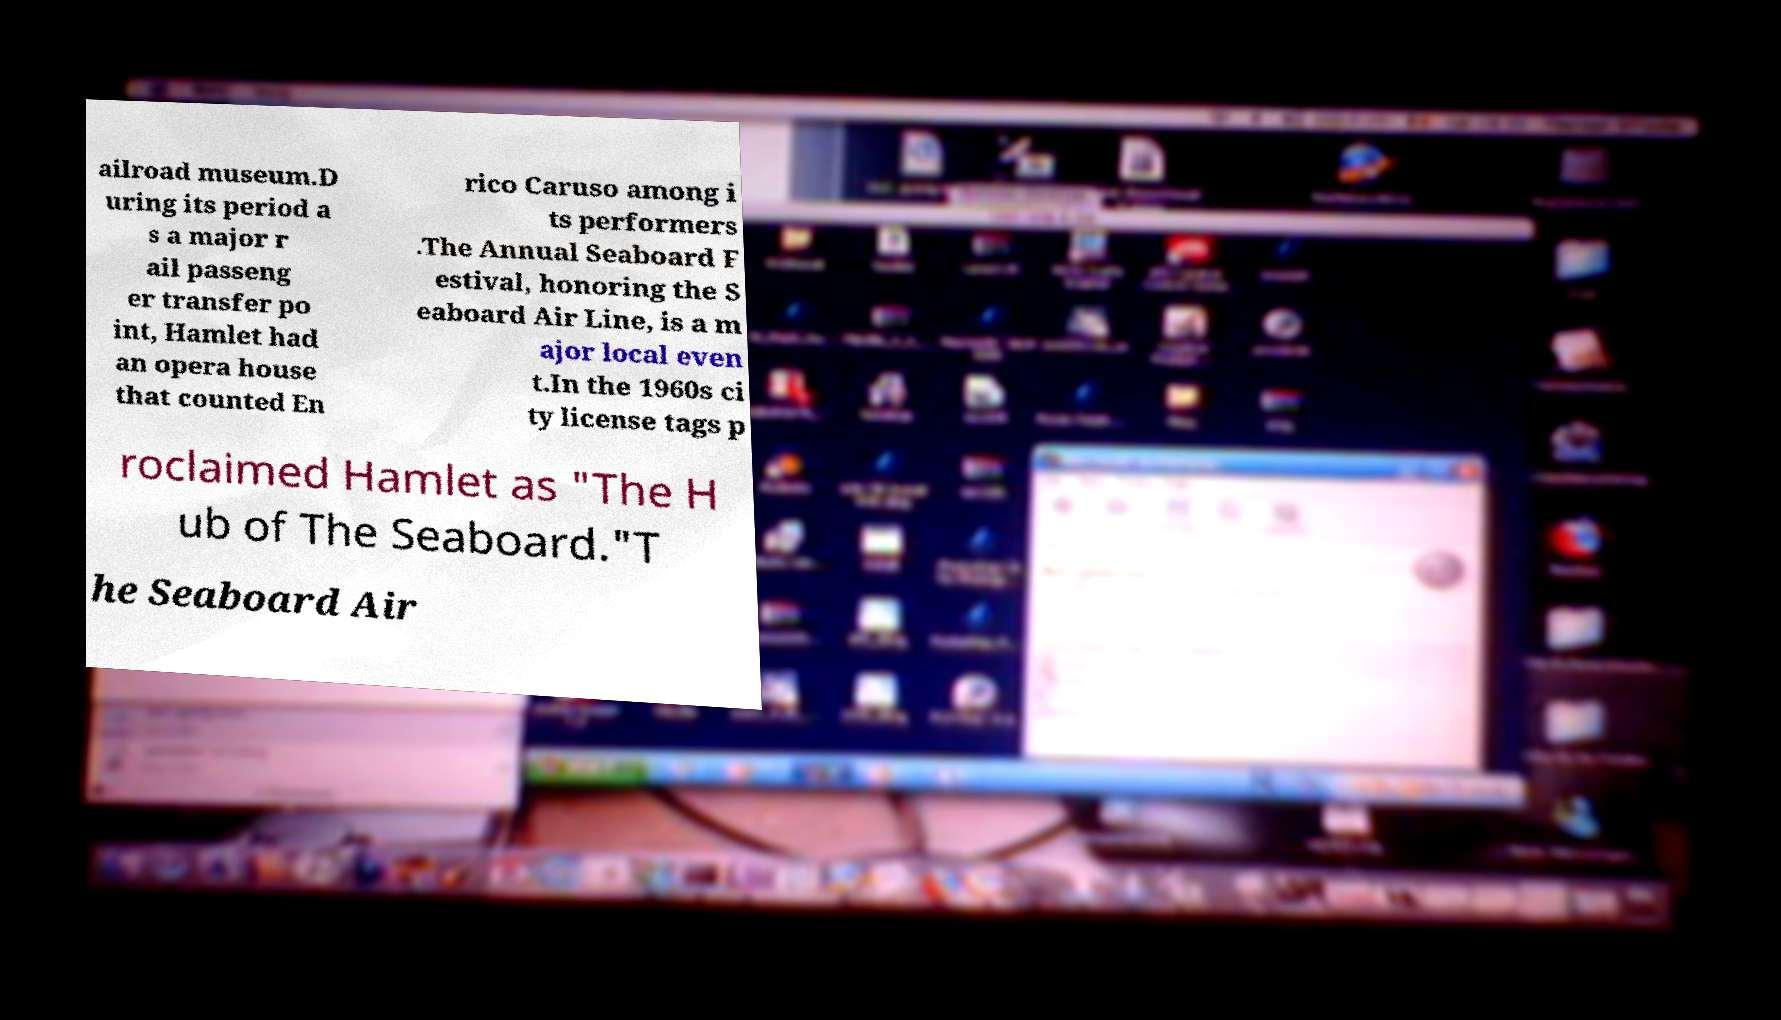Can you accurately transcribe the text from the provided image for me? ailroad museum.D uring its period a s a major r ail passeng er transfer po int, Hamlet had an opera house that counted En rico Caruso among i ts performers .The Annual Seaboard F estival, honoring the S eaboard Air Line, is a m ajor local even t.In the 1960s ci ty license tags p roclaimed Hamlet as "The H ub of The Seaboard."T he Seaboard Air 